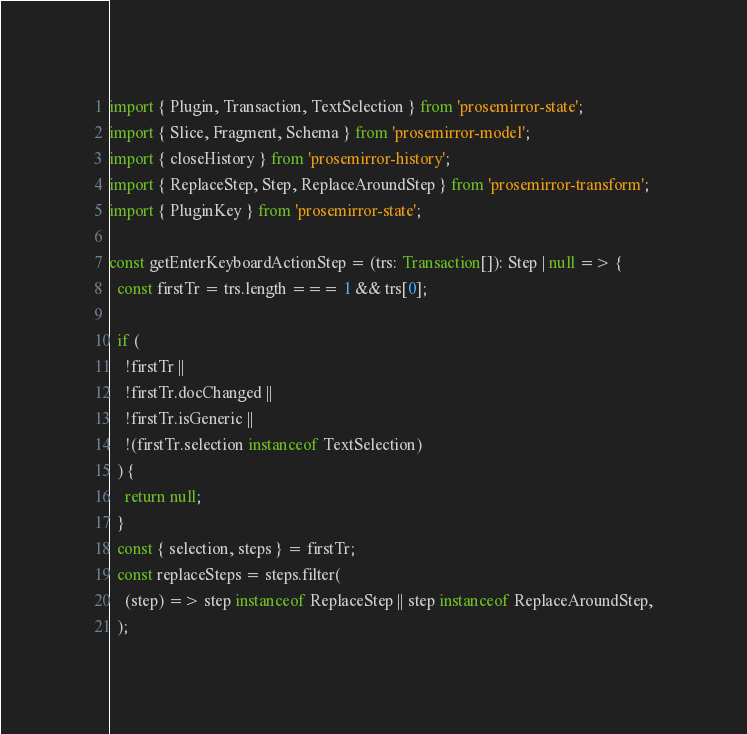<code> <loc_0><loc_0><loc_500><loc_500><_TypeScript_>import { Plugin, Transaction, TextSelection } from 'prosemirror-state';
import { Slice, Fragment, Schema } from 'prosemirror-model';
import { closeHistory } from 'prosemirror-history';
import { ReplaceStep, Step, ReplaceAroundStep } from 'prosemirror-transform';
import { PluginKey } from 'prosemirror-state';

const getEnterKeyboardActionStep = (trs: Transaction[]): Step | null => {
  const firstTr = trs.length === 1 && trs[0];

  if (
    !firstTr ||
    !firstTr.docChanged ||
    !firstTr.isGeneric ||
    !(firstTr.selection instanceof TextSelection)
  ) {
    return null;
  }
  const { selection, steps } = firstTr;
  const replaceSteps = steps.filter(
    (step) => step instanceof ReplaceStep || step instanceof ReplaceAroundStep,
  );
</code> 